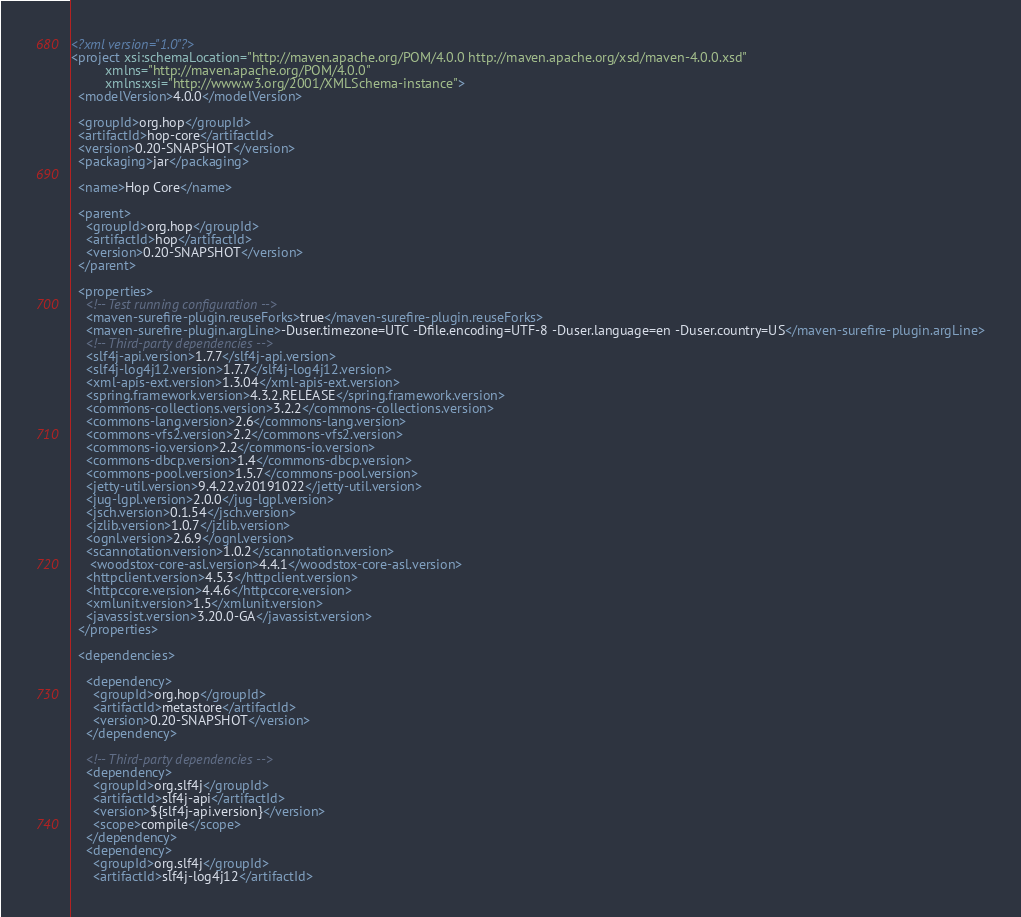Convert code to text. <code><loc_0><loc_0><loc_500><loc_500><_XML_><?xml version="1.0"?>
<project xsi:schemaLocation="http://maven.apache.org/POM/4.0.0 http://maven.apache.org/xsd/maven-4.0.0.xsd"
         xmlns="http://maven.apache.org/POM/4.0.0"
         xmlns:xsi="http://www.w3.org/2001/XMLSchema-instance">
  <modelVersion>4.0.0</modelVersion>

  <groupId>org.hop</groupId>
  <artifactId>hop-core</artifactId>
  <version>0.20-SNAPSHOT</version>
  <packaging>jar</packaging>

  <name>Hop Core</name>

  <parent>
    <groupId>org.hop</groupId>
    <artifactId>hop</artifactId>
    <version>0.20-SNAPSHOT</version>
  </parent>

  <properties>
    <!-- Test running configuration -->
    <maven-surefire-plugin.reuseForks>true</maven-surefire-plugin.reuseForks>
    <maven-surefire-plugin.argLine>-Duser.timezone=UTC -Dfile.encoding=UTF-8 -Duser.language=en -Duser.country=US</maven-surefire-plugin.argLine>
    <!-- Third-party dependencies -->
    <slf4j-api.version>1.7.7</slf4j-api.version>
    <slf4j-log4j12.version>1.7.7</slf4j-log4j12.version>
    <xml-apis-ext.version>1.3.04</xml-apis-ext.version>
    <spring.framework.version>4.3.2.RELEASE</spring.framework.version>
    <commons-collections.version>3.2.2</commons-collections.version>
    <commons-lang.version>2.6</commons-lang.version>
    <commons-vfs2.version>2.2</commons-vfs2.version>
    <commons-io.version>2.2</commons-io.version>
    <commons-dbcp.version>1.4</commons-dbcp.version>
    <commons-pool.version>1.5.7</commons-pool.version>
    <jetty-util.version>9.4.22.v20191022</jetty-util.version>
    <jug-lgpl.version>2.0.0</jug-lgpl.version>
    <jsch.version>0.1.54</jsch.version>
    <jzlib.version>1.0.7</jzlib.version>
    <ognl.version>2.6.9</ognl.version>
    <scannotation.version>1.0.2</scannotation.version>
     <woodstox-core-asl.version>4.4.1</woodstox-core-asl.version>
    <httpclient.version>4.5.3</httpclient.version>
    <httpccore.version>4.4.6</httpccore.version>
    <xmlunit.version>1.5</xmlunit.version>
    <javassist.version>3.20.0-GA</javassist.version>
  </properties>

  <dependencies>

    <dependency>
      <groupId>org.hop</groupId>
      <artifactId>metastore</artifactId>
      <version>0.20-SNAPSHOT</version>
    </dependency>

    <!-- Third-party dependencies -->
    <dependency>
      <groupId>org.slf4j</groupId>
      <artifactId>slf4j-api</artifactId>
      <version>${slf4j-api.version}</version>
      <scope>compile</scope>
    </dependency>
    <dependency>
      <groupId>org.slf4j</groupId>
      <artifactId>slf4j-log4j12</artifactId></code> 